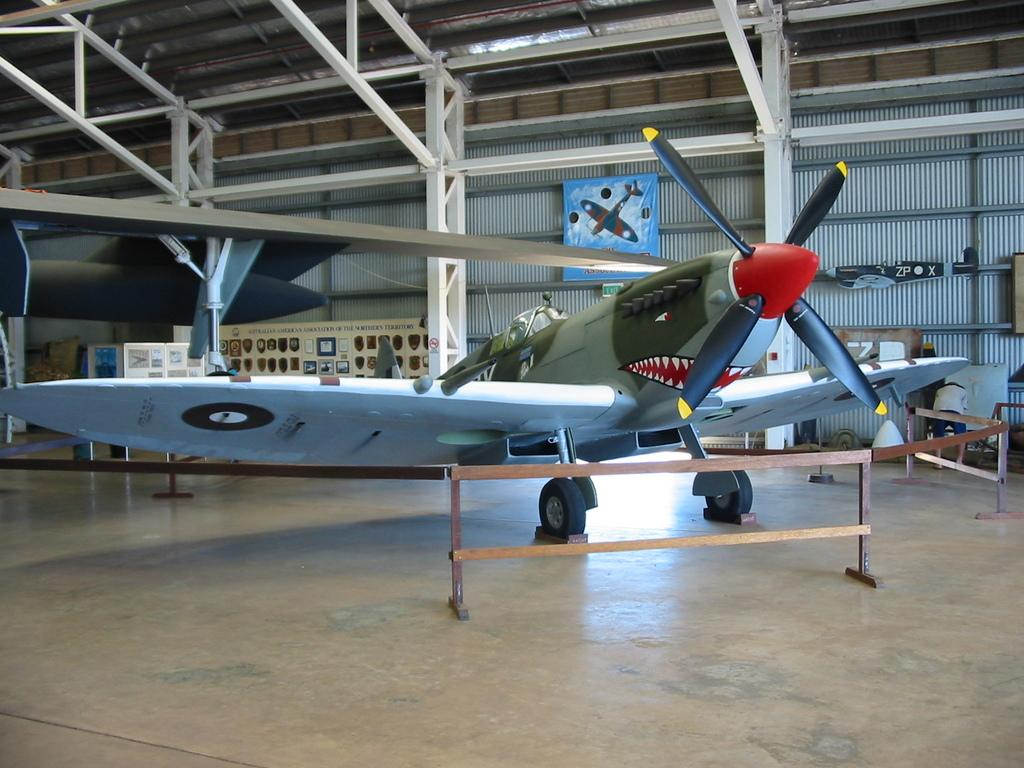What is the main subject of the image? The main subject of the image is an aircraft. What can be seen in the background of the image? There are rods and poles in the background of the image. What is on the wall in the image? There is a wall with posters on it in the image. What color is the blood on the hand in the image? There is no hand or blood present in the image; it features an aircraft with rods and poles in the background and a wall with posters. 